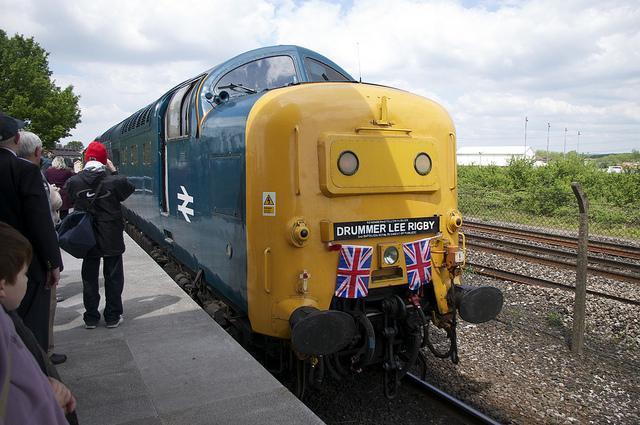How many people are there?
Give a very brief answer. 3. 